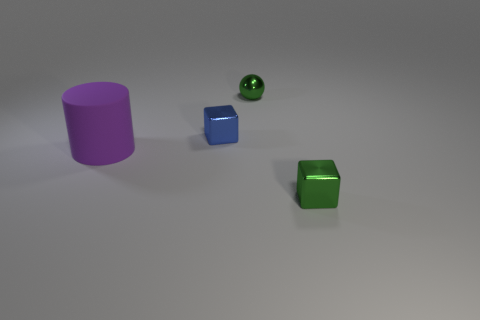Are there any other things that have the same shape as the large rubber object?
Your answer should be compact. No. Is there any other thing that has the same material as the small green block?
Your answer should be compact. Yes. Do the tiny ball and the rubber object have the same color?
Give a very brief answer. No. There is a green thing that is the same material as the green block; what is its shape?
Keep it short and to the point. Sphere. How many tiny green metallic things are the same shape as the small blue metallic thing?
Your answer should be very brief. 1. The tiny green thing in front of the small shiny block behind the tiny green cube is what shape?
Give a very brief answer. Cube. There is a shiny cube that is behind the purple object; is it the same size as the large matte cylinder?
Your answer should be very brief. No. There is a thing that is both in front of the blue metal thing and left of the green sphere; how big is it?
Your answer should be compact. Large. How many blue shiny cubes are the same size as the green cube?
Offer a very short reply. 1. There is a small metal object behind the tiny blue block; what number of blocks are on the right side of it?
Offer a very short reply. 1. 